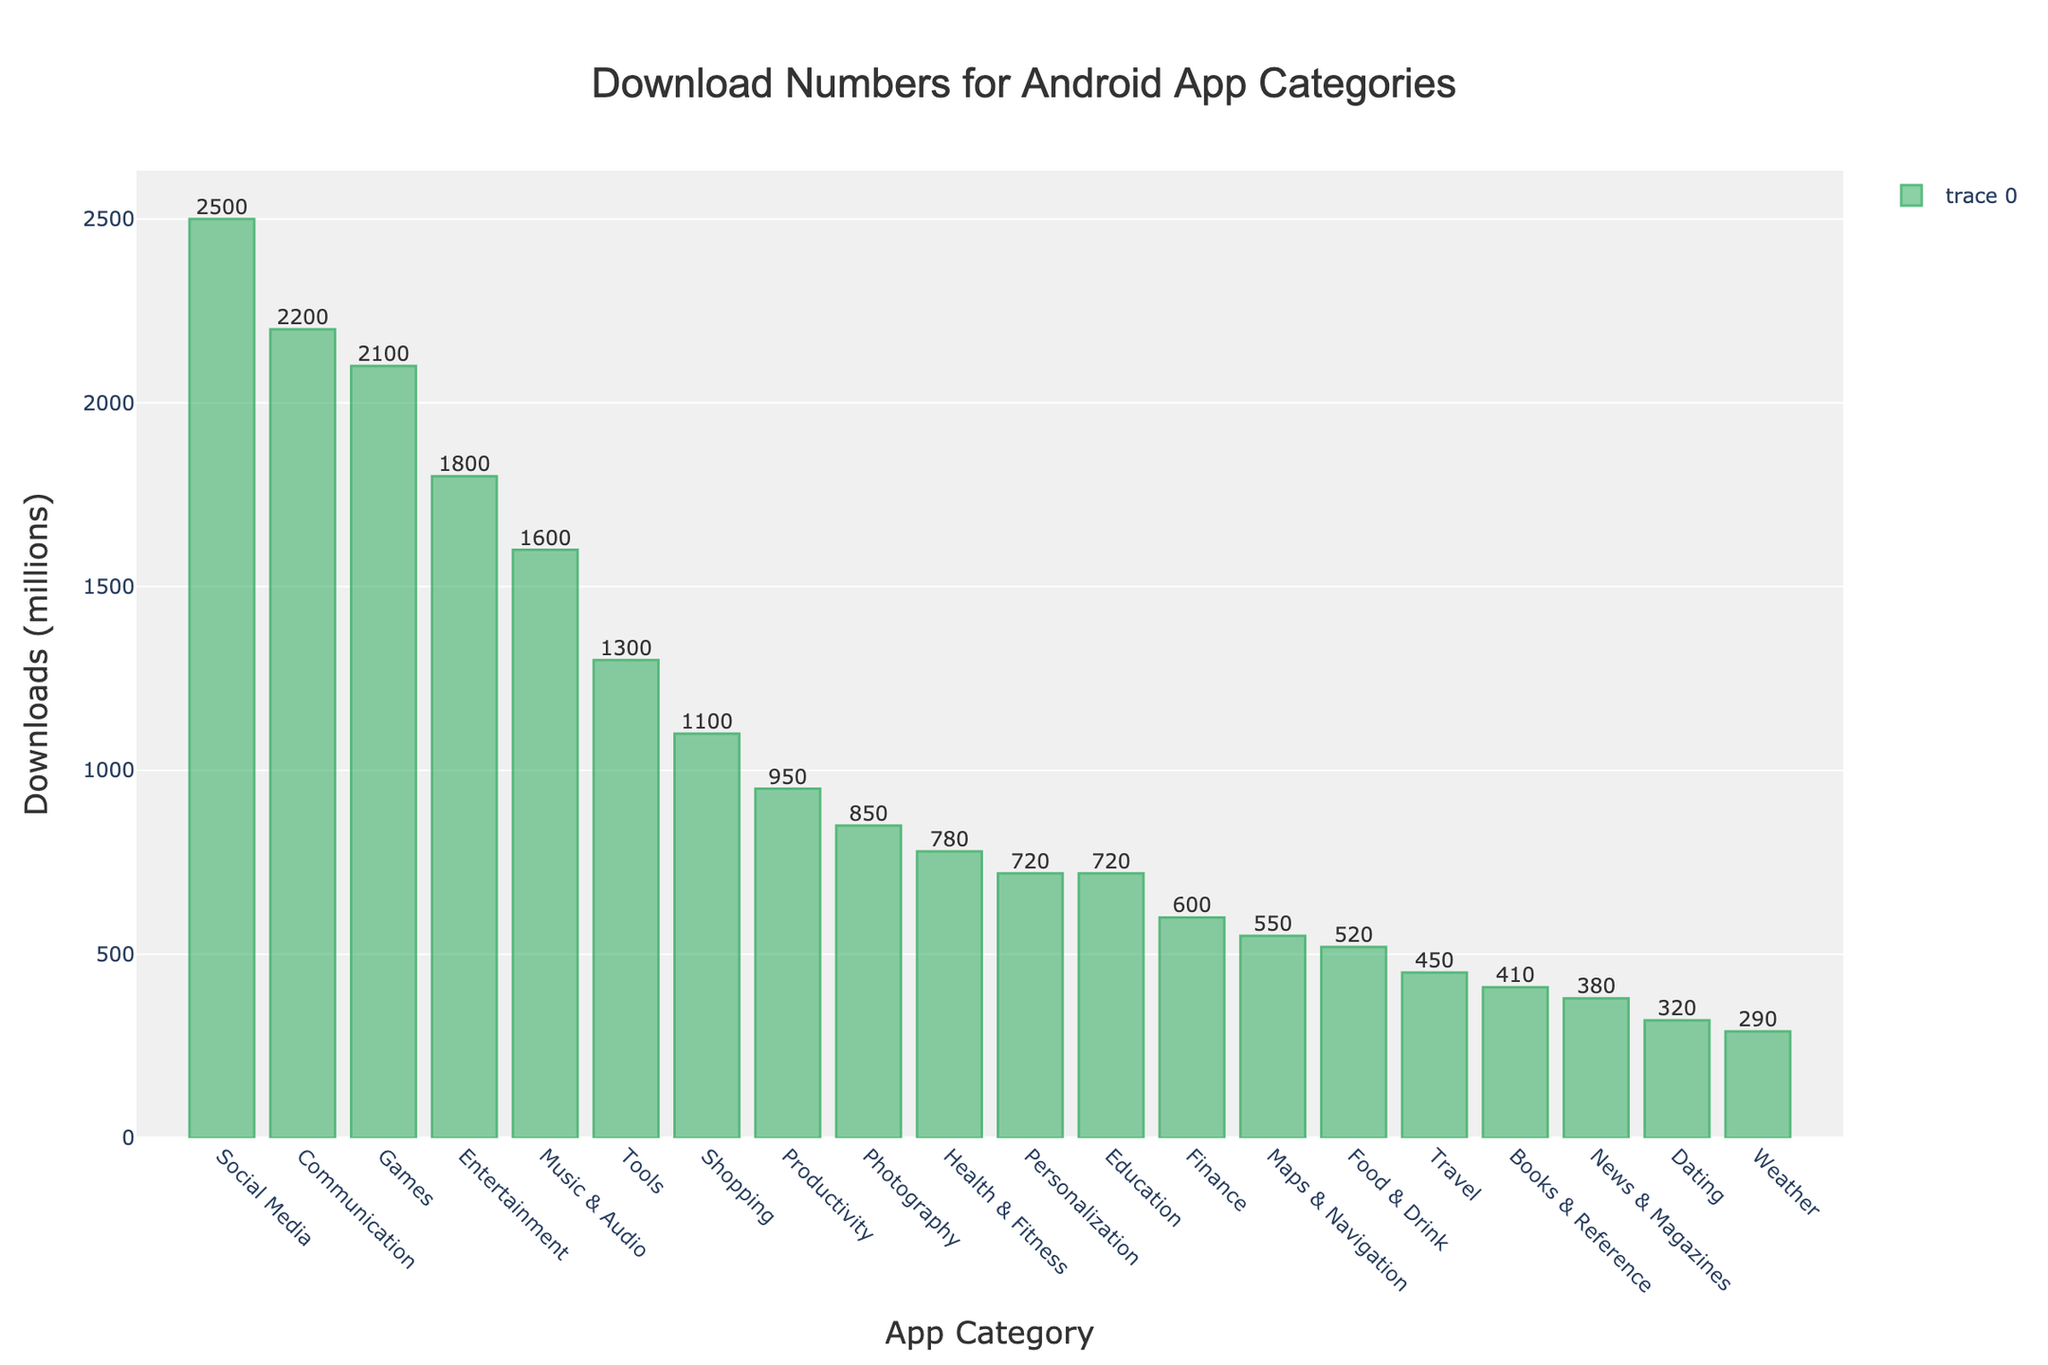Which app category has the highest number of downloads? The bar chart shows Social Media at the highest point on the chart, indicating it has the most downloads.
Answer: Social Media Which category has the second most downloads after Social Media? The bar for Communication is slightly lower than Social Media, showing it is the second highest.
Answer: Communication How many downloads does the Education category have? The bar for Education reaches up to 720 million.
Answer: 720 million Which has more downloads, Photography or Finance? The bar for Photography is higher than the bar for Finance.
Answer: Photography What is the combined number of downloads for the Education and Personalization categories? Education has 720 million and Personalization also has 720 million, their sum is 720+720.
Answer: 1440 million Compare the download numbers between Games and Tools categories. Which has more and by how much? Games have 2100 million and Tools have 1300 million, the difference is 2100-1300.
Answer: Games by 800 million Which app category has the least downloads? The bar for Weather is the lowest, indicating it has the least downloads.
Answer: Weather What is the average download number for Social Media, Games, and Communication categories? Sum of downloads for Social Media (2500), Games (2100), and Communication (2200) is 6800. Average is 6800/3.
Answer: 2266.67 million How many categories have more than 1000 million downloads? Social Media, Games, Communication, Entertainment, Tools, Shopping, and Music & Audio have bars over 1000 million. Count these categories.
Answer: 7 categories What is the difference in downloads between Music & Audio and Entertainment? Music & Audio has 1600 million downloads and Entertainment has 1800 million downloads, the difference is 1800-1600.
Answer: 200 million 